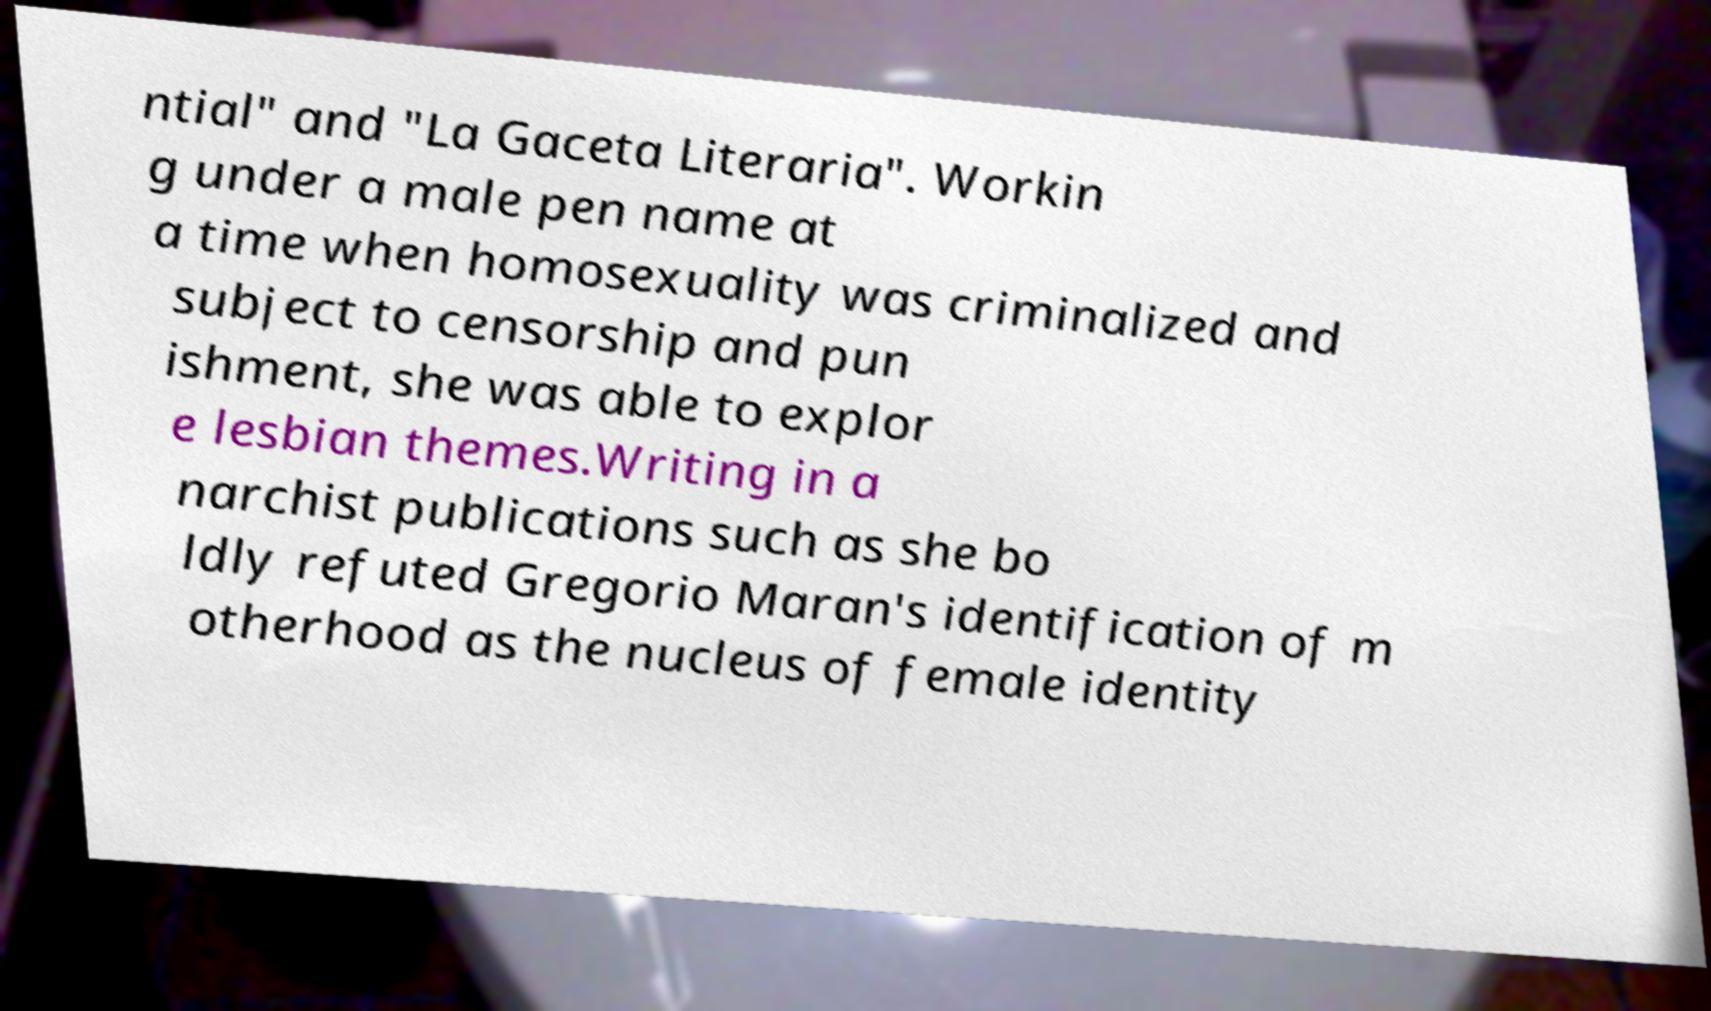For documentation purposes, I need the text within this image transcribed. Could you provide that? ntial" and "La Gaceta Literaria". Workin g under a male pen name at a time when homosexuality was criminalized and subject to censorship and pun ishment, she was able to explor e lesbian themes.Writing in a narchist publications such as she bo ldly refuted Gregorio Maran's identification of m otherhood as the nucleus of female identity 